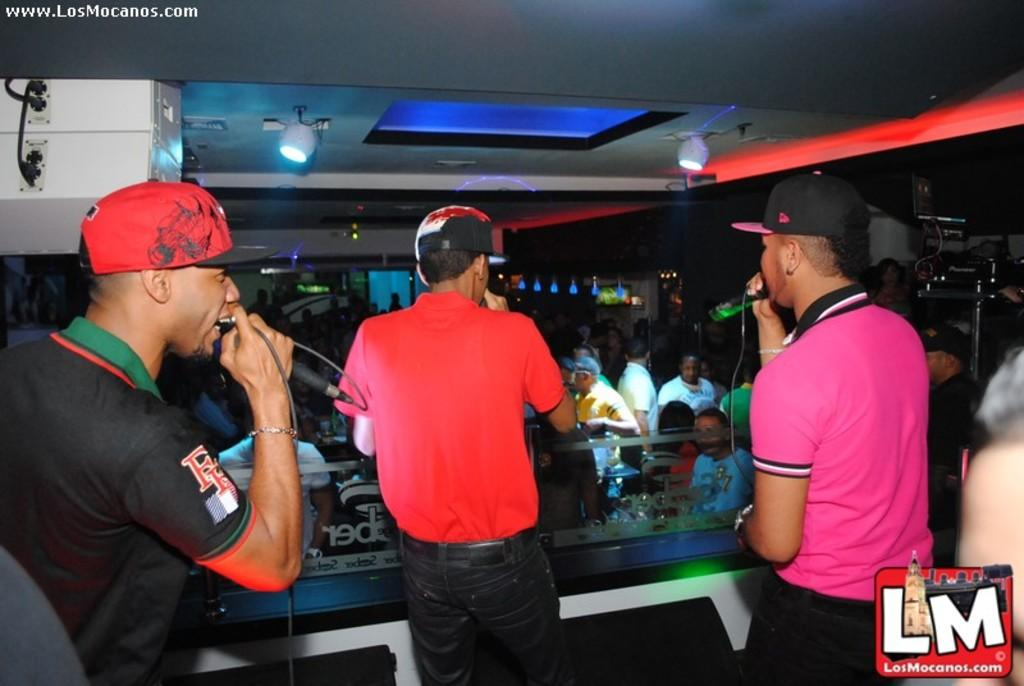What are the people in the image doing? The people in the image are standing and holding microphones. What else can be seen in the image besides the people? There is a crowd, lights, a door, and walls visible in the image. What time is displayed on the clock in the image? There is no clock present in the image. Can you describe the window in the image? There is no window present in the image. 